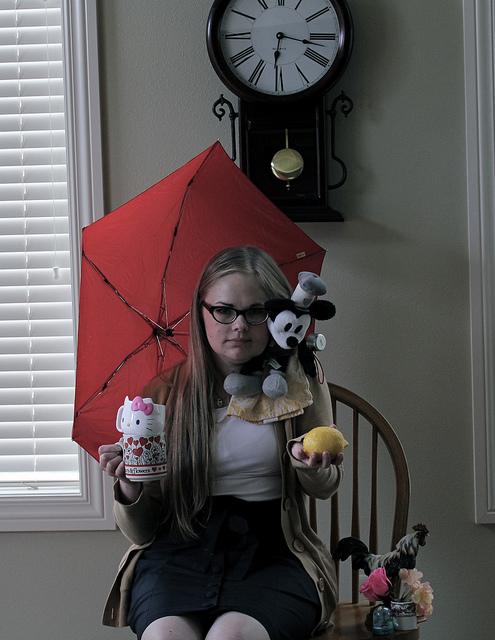What is in her left hand?
Answer briefly. Lemon. Is steamboat willy on the girls shoulder?
Give a very brief answer. Yes. Was this photo taken in the morning?
Answer briefly. No. 